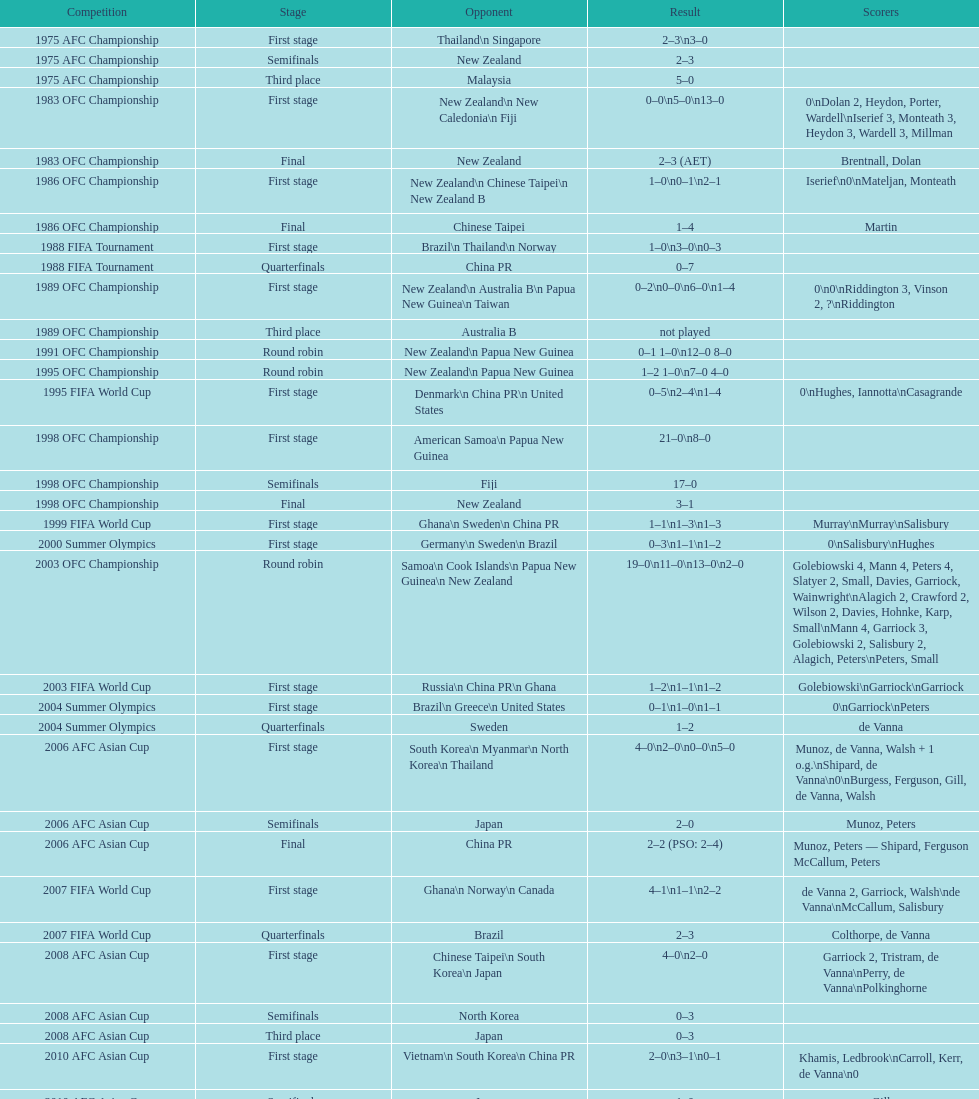What was the total goals made in the 1983 ofc championship? 18. 